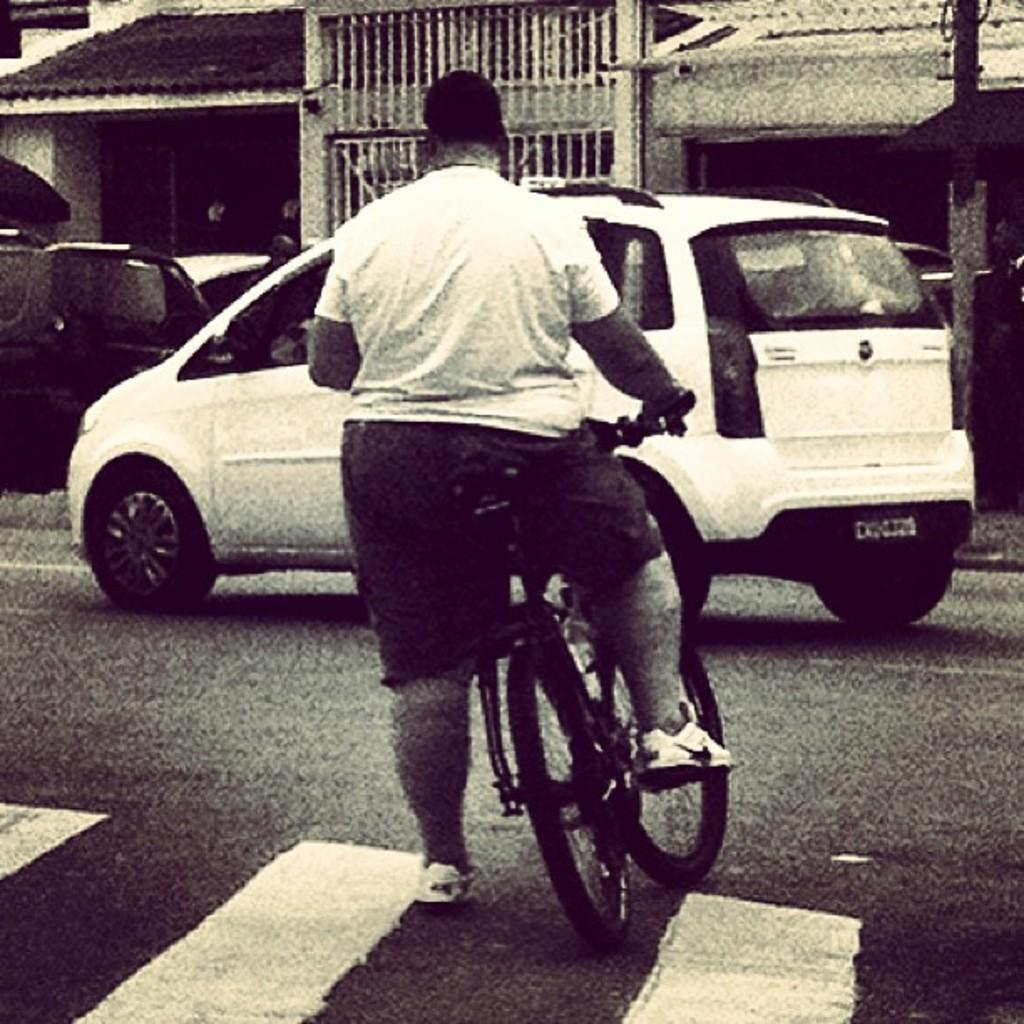What is the person in the image holding? The person is holding a bicycle. What can be seen in the background of the image? There are vehicles and a grill in the background. What type of whistle is the person using to signal their presence in the image? There is no whistle present in the image; the person is simply holding a bicycle. 